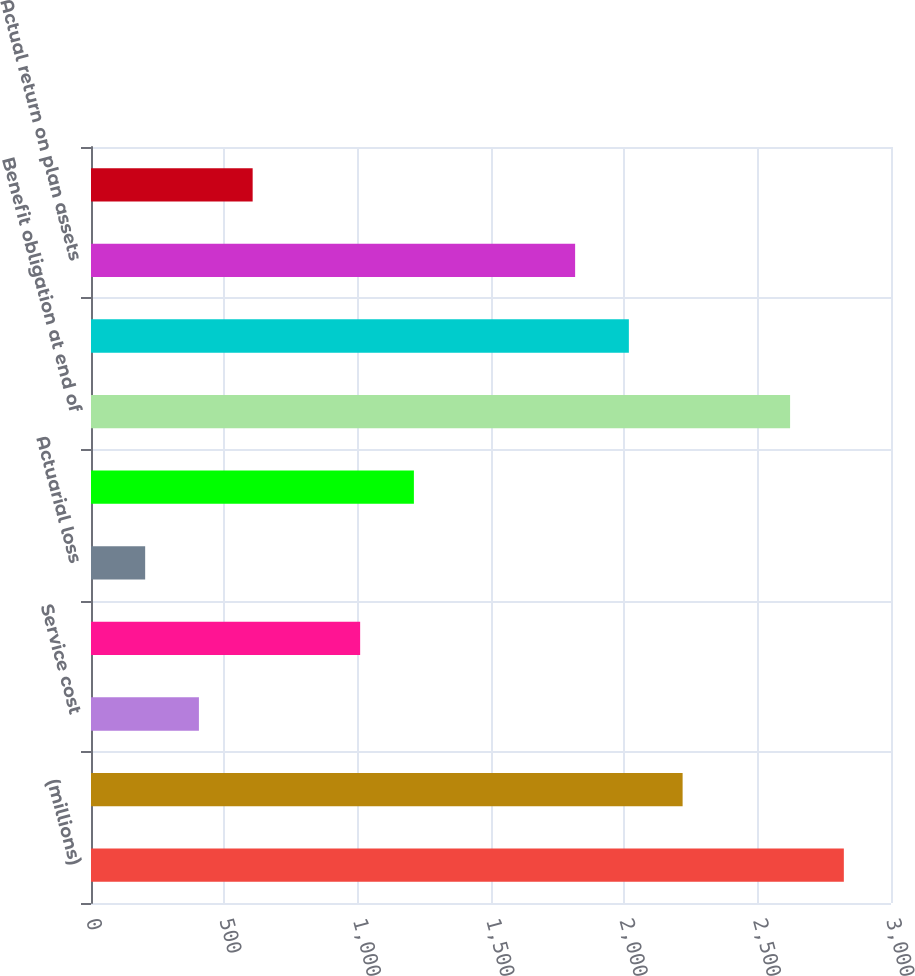Convert chart to OTSL. <chart><loc_0><loc_0><loc_500><loc_500><bar_chart><fcel>(millions)<fcel>Benefit obligation at<fcel>Service cost<fcel>Interest costs<fcel>Actuarial loss<fcel>Benefits paid<fcel>Benefit obligation at end of<fcel>Fair value of plan assets at<fcel>Actual return on plan assets<fcel>Employer contributions<nl><fcel>2823.16<fcel>2218.54<fcel>404.68<fcel>1009.3<fcel>203.14<fcel>1210.84<fcel>2621.62<fcel>2017<fcel>1815.46<fcel>606.22<nl></chart> 